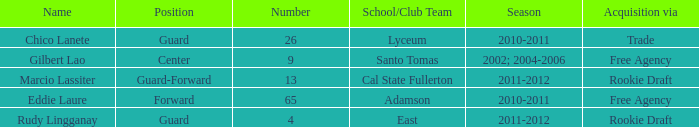In what season was a free agency acquisition made, with a number higher than 9? 2010-2011. 